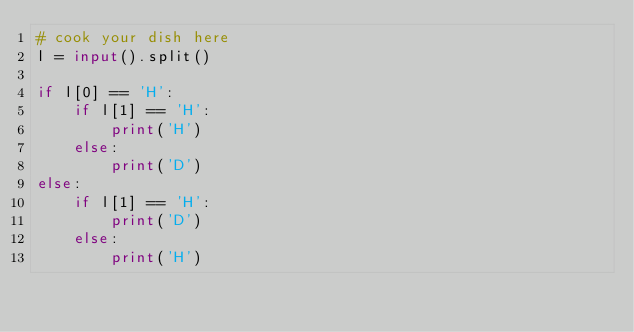<code> <loc_0><loc_0><loc_500><loc_500><_Python_># cook your dish here
l = input().split()

if l[0] == 'H':
    if l[1] == 'H':
        print('H')
    else:
        print('D')
else:
    if l[1] == 'H':
        print('D')
    else:
        print('H')</code> 